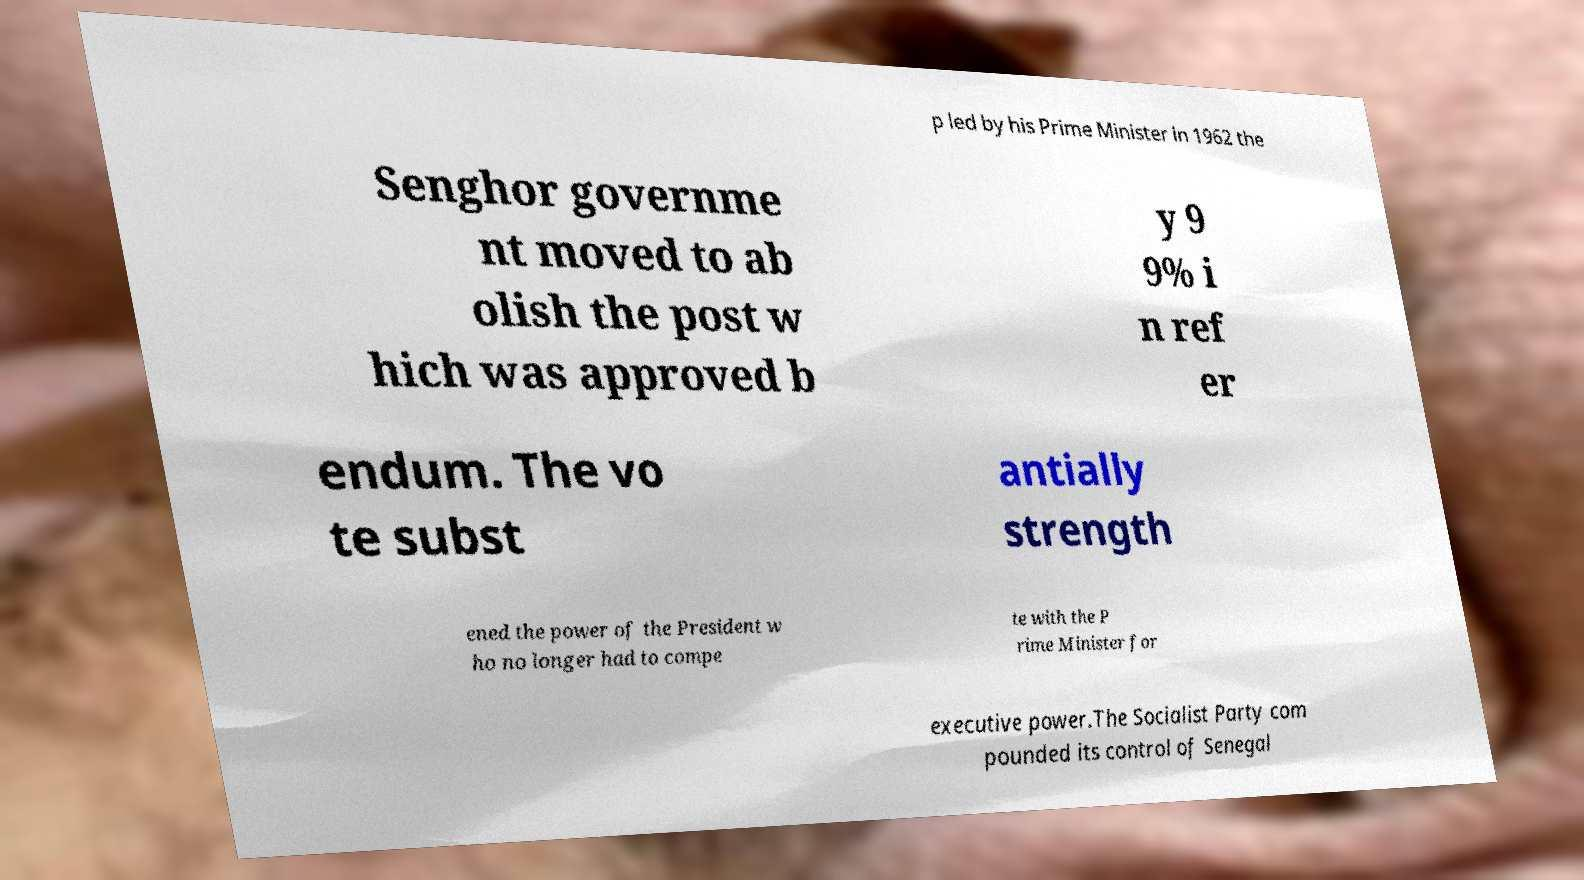Could you extract and type out the text from this image? p led by his Prime Minister in 1962 the Senghor governme nt moved to ab olish the post w hich was approved b y 9 9% i n ref er endum. The vo te subst antially strength ened the power of the President w ho no longer had to compe te with the P rime Minister for executive power.The Socialist Party com pounded its control of Senegal 